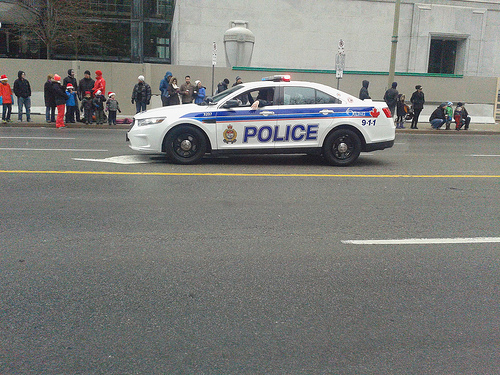<image>
Is there a police car in the street? Yes. The police car is contained within or inside the street, showing a containment relationship. 